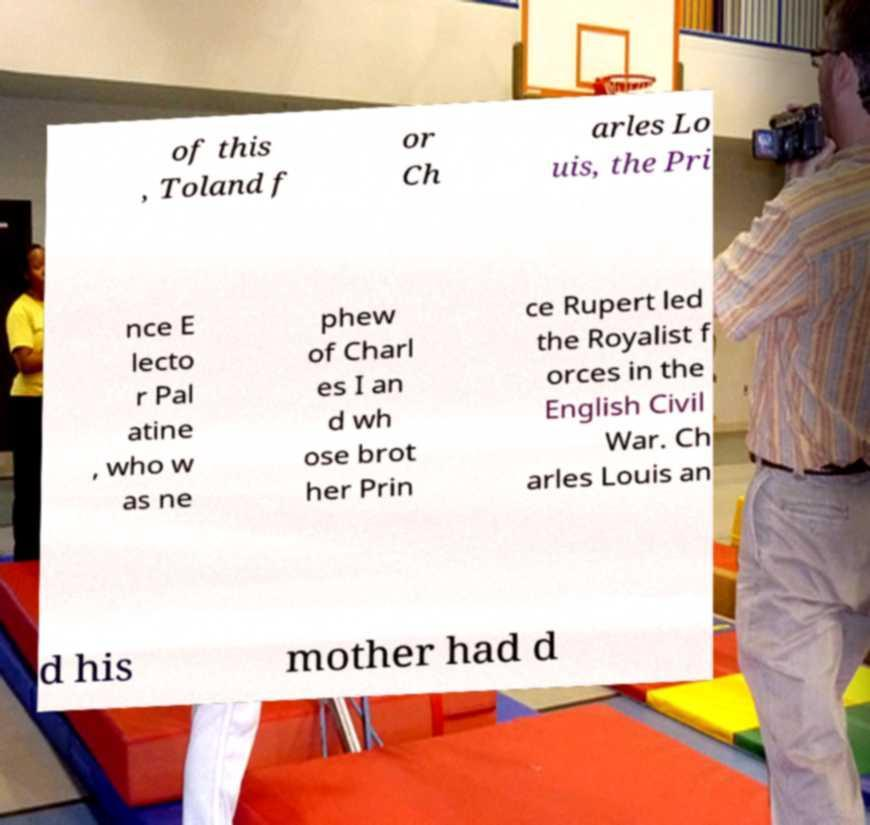Can you accurately transcribe the text from the provided image for me? of this , Toland f or Ch arles Lo uis, the Pri nce E lecto r Pal atine , who w as ne phew of Charl es I an d wh ose brot her Prin ce Rupert led the Royalist f orces in the English Civil War. Ch arles Louis an d his mother had d 